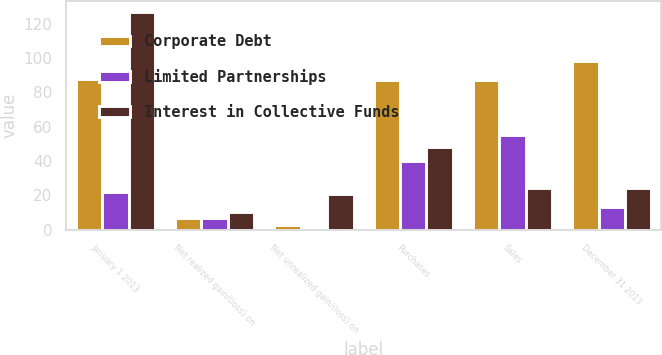Convert chart to OTSL. <chart><loc_0><loc_0><loc_500><loc_500><stacked_bar_chart><ecel><fcel>January 1 2013<fcel>Net realized gain/(loss) on<fcel>Net unrealized gain/(loss) on<fcel>Purchases<fcel>Sales<fcel>December 31 2013<nl><fcel>Corporate Debt<fcel>88<fcel>7<fcel>3<fcel>87<fcel>87<fcel>98<nl><fcel>Limited Partnerships<fcel>22<fcel>7<fcel>1<fcel>40<fcel>55<fcel>13<nl><fcel>Interest in Collective Funds<fcel>127<fcel>10<fcel>21<fcel>48<fcel>24<fcel>24<nl></chart> 